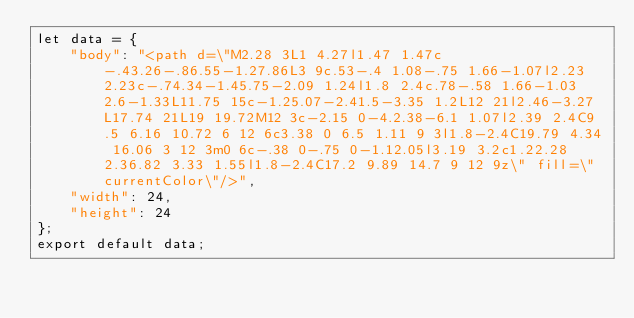<code> <loc_0><loc_0><loc_500><loc_500><_JavaScript_>let data = {
	"body": "<path d=\"M2.28 3L1 4.27l1.47 1.47c-.43.26-.86.55-1.27.86L3 9c.53-.4 1.08-.75 1.66-1.07l2.23 2.23c-.74.34-1.45.75-2.09 1.24l1.8 2.4c.78-.58 1.66-1.03 2.6-1.33L11.75 15c-1.25.07-2.41.5-3.35 1.2L12 21l2.46-3.27L17.74 21L19 19.72M12 3c-2.15 0-4.2.38-6.1 1.07l2.39 2.4C9.5 6.16 10.72 6 12 6c3.38 0 6.5 1.11 9 3l1.8-2.4C19.79 4.34 16.06 3 12 3m0 6c-.38 0-.75 0-1.12.05l3.19 3.2c1.22.28 2.36.82 3.33 1.55l1.8-2.4C17.2 9.89 14.7 9 12 9z\" fill=\"currentColor\"/>",
	"width": 24,
	"height": 24
};
export default data;
</code> 